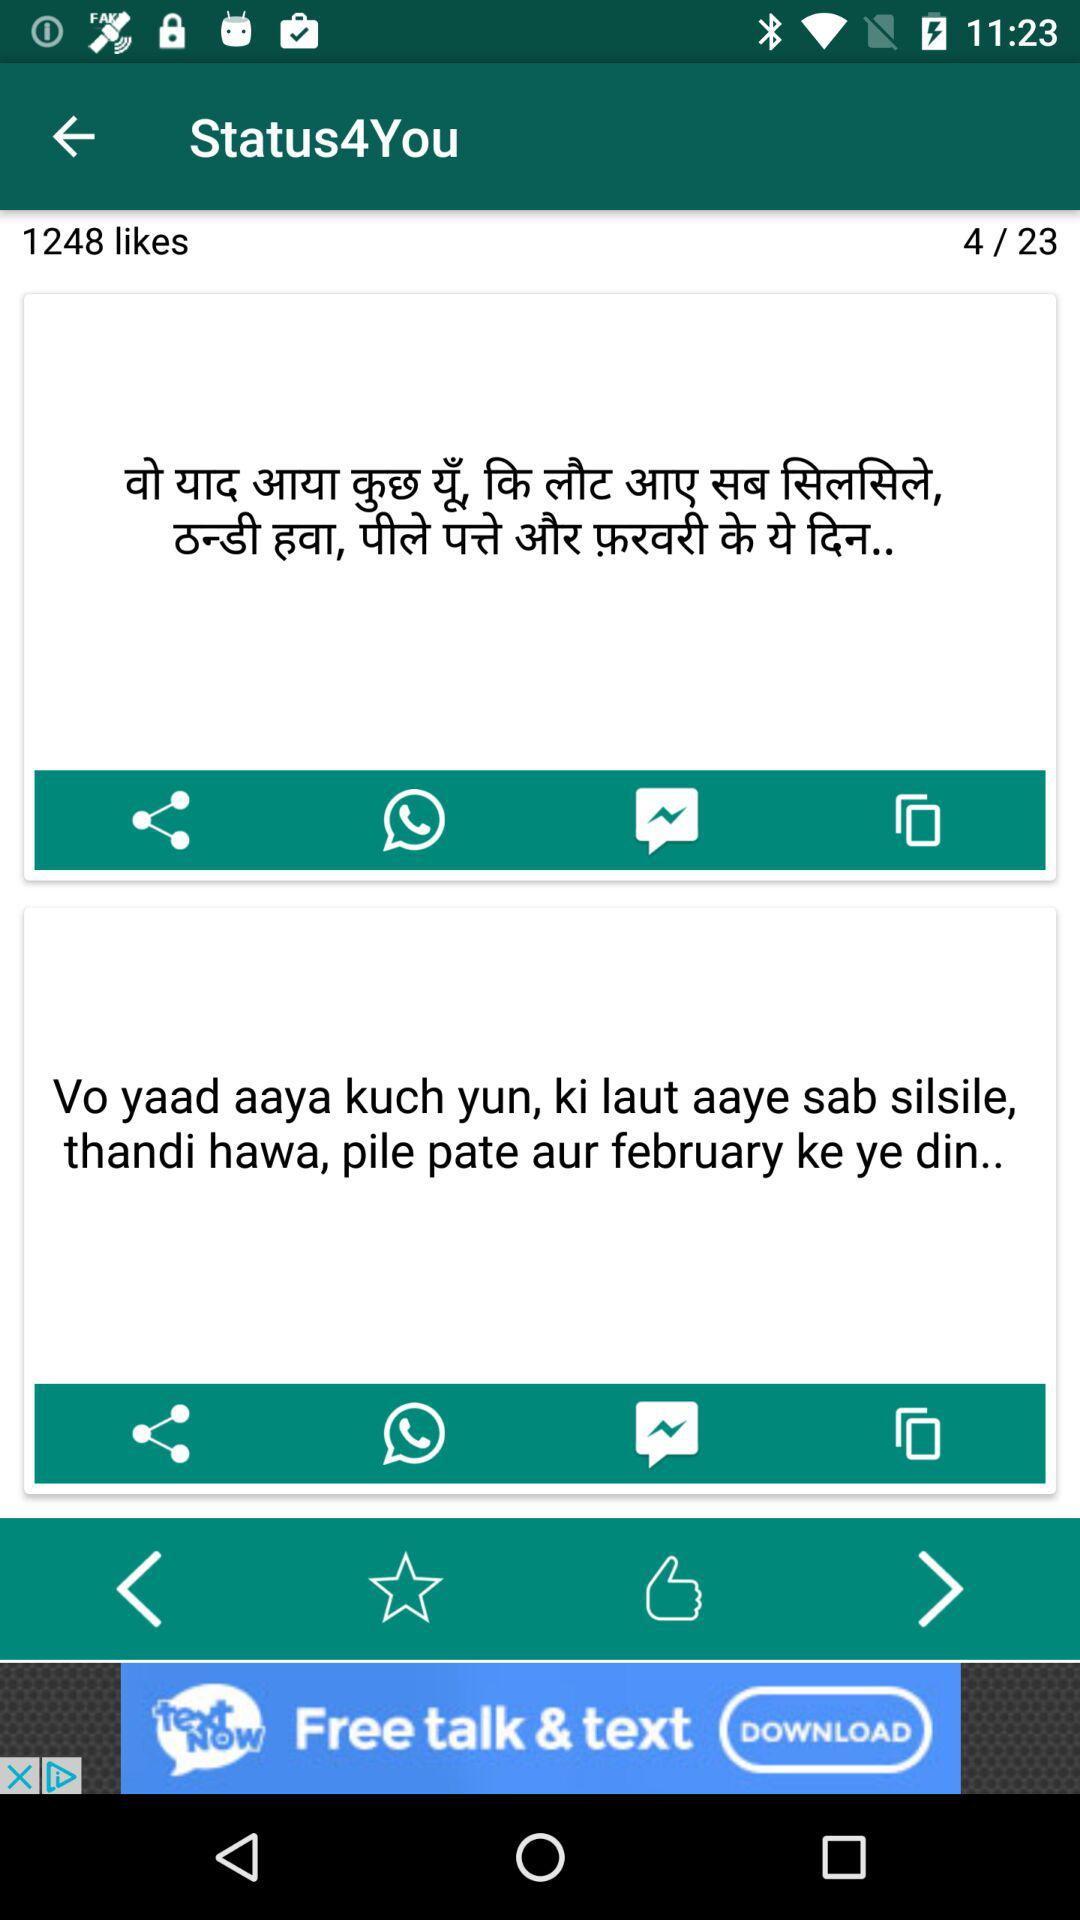How many likes are there? There are 1248 likes. 